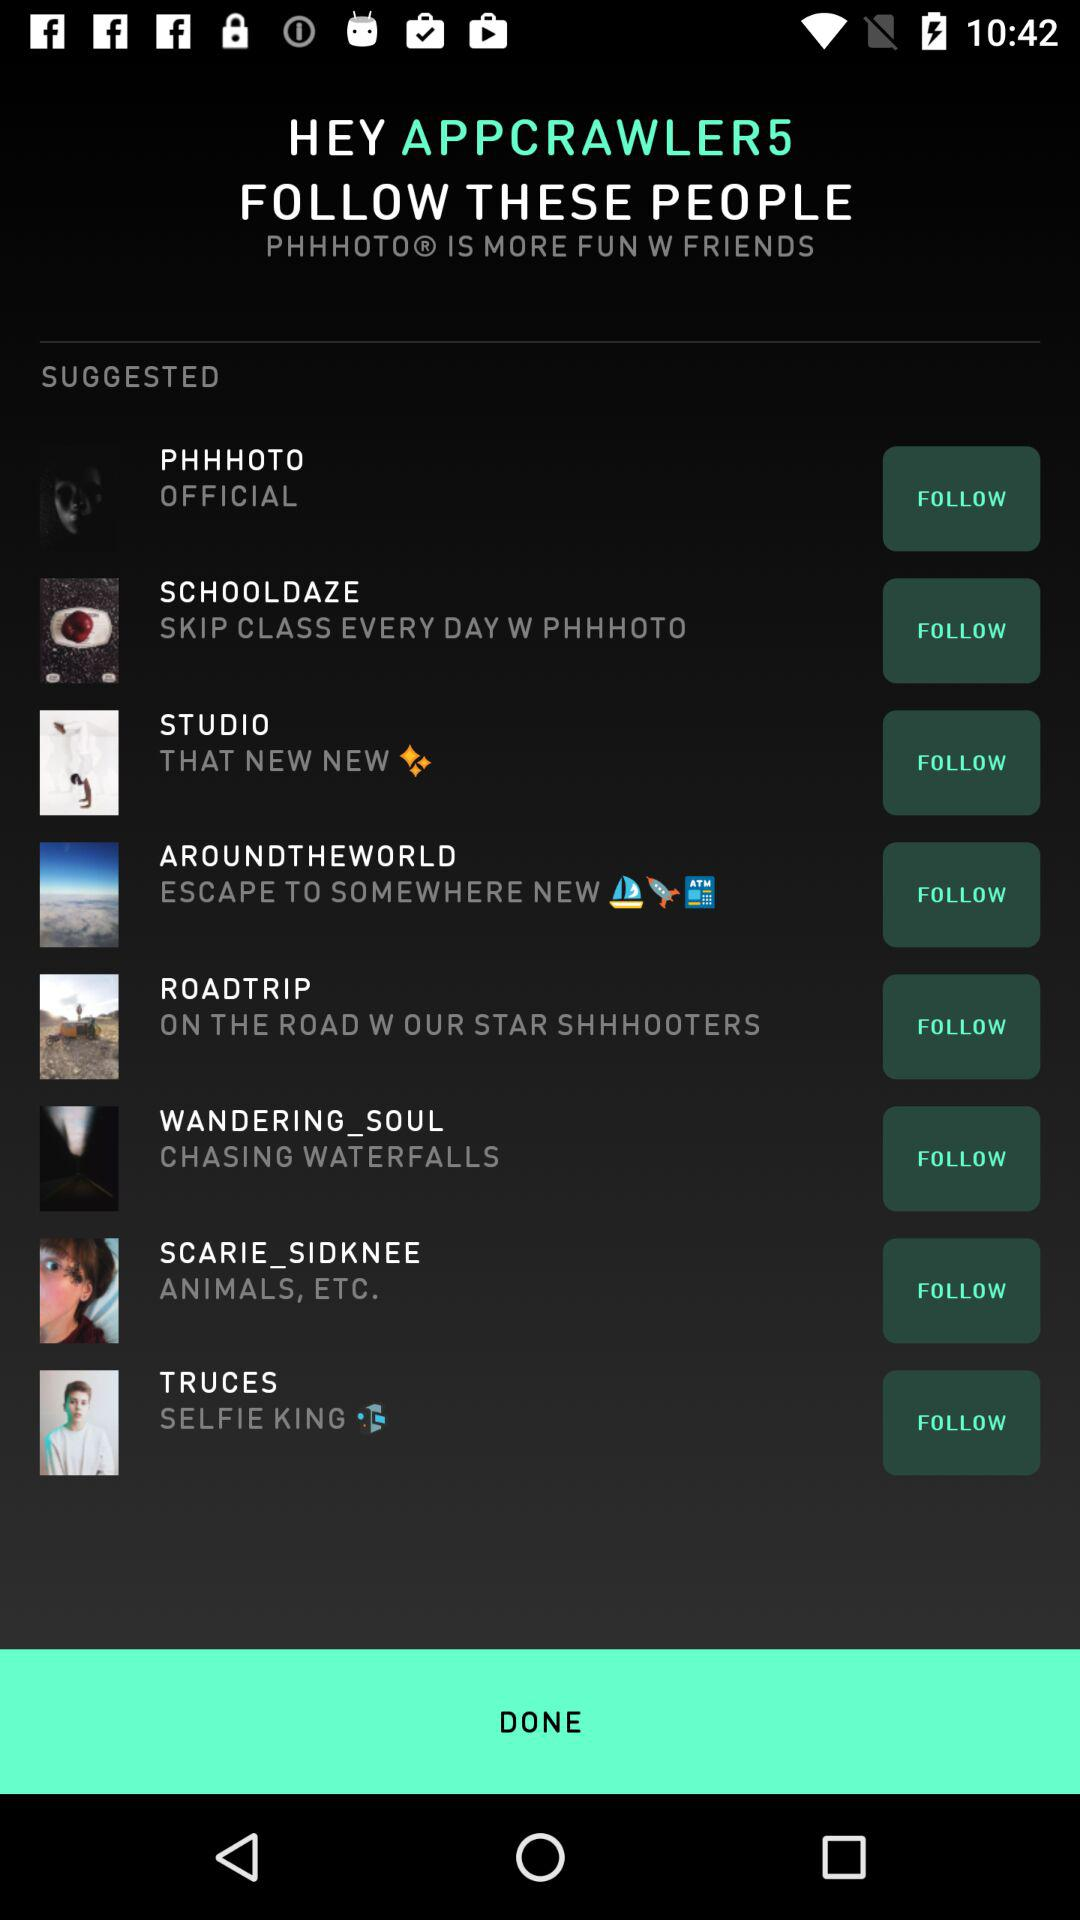What is the username? The username is APPCRAWLER5. 